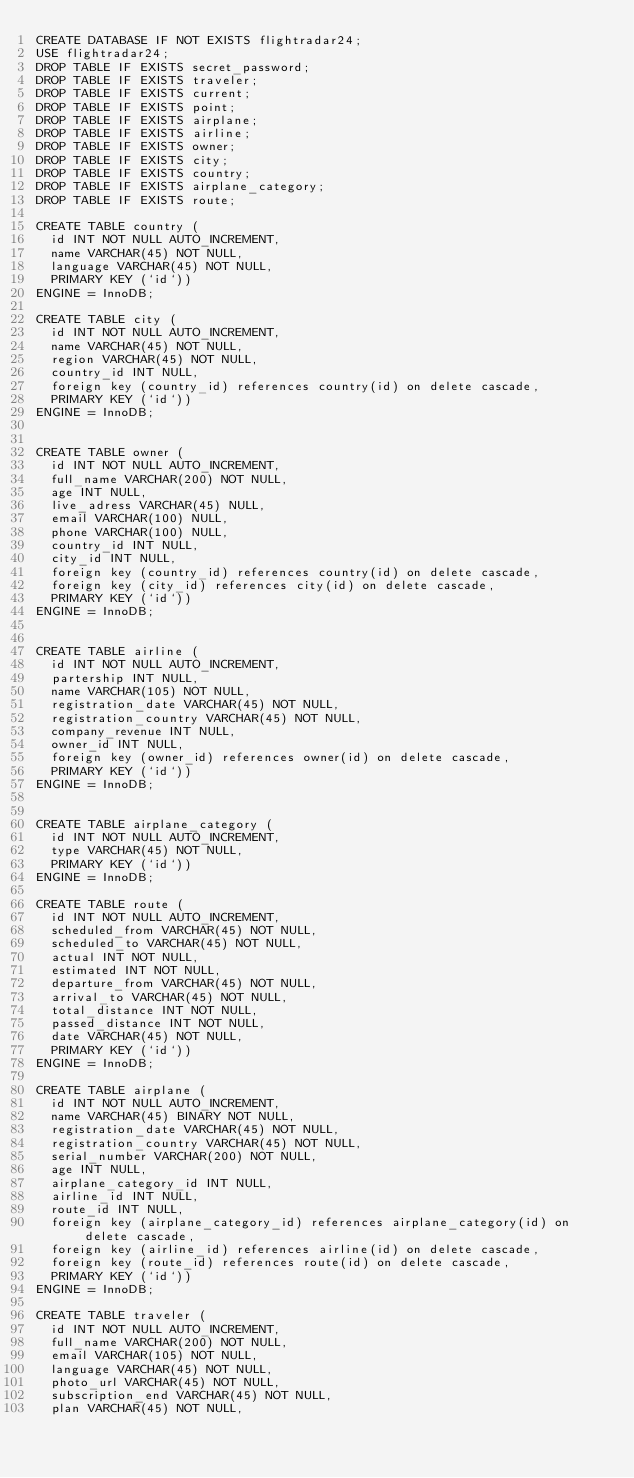<code> <loc_0><loc_0><loc_500><loc_500><_SQL_>CREATE DATABASE IF NOT EXISTS flightradar24;
USE flightradar24;
DROP TABLE IF EXISTS secret_password;
DROP TABLE IF EXISTS traveler;
DROP TABLE IF EXISTS current;
DROP TABLE IF EXISTS point;
DROP TABLE IF EXISTS airplane;
DROP TABLE IF EXISTS airline;
DROP TABLE IF EXISTS owner;
DROP TABLE IF EXISTS city;
DROP TABLE IF EXISTS country;
DROP TABLE IF EXISTS airplane_category;
DROP TABLE IF EXISTS route;

CREATE TABLE country (
  id INT NOT NULL AUTO_INCREMENT,
  name VARCHAR(45) NOT NULL,
  language VARCHAR(45) NOT NULL,
  PRIMARY KEY (`id`))
ENGINE = InnoDB;

CREATE TABLE city (
  id INT NOT NULL AUTO_INCREMENT,
  name VARCHAR(45) NOT NULL,
  region VARCHAR(45) NOT NULL,
  country_id INT NULL,
  foreign key (country_id) references country(id) on delete cascade,
  PRIMARY KEY (`id`))
ENGINE = InnoDB;


CREATE TABLE owner (
  id INT NOT NULL AUTO_INCREMENT,
  full_name VARCHAR(200) NOT NULL,
  age INT NULL,
  live_adress VARCHAR(45) NULL,
  email VARCHAR(100) NULL,
  phone VARCHAR(100) NULL,
  country_id INT NULL,
  city_id INT NULL,
  foreign key (country_id) references country(id) on delete cascade,
  foreign key (city_id) references city(id) on delete cascade,
  PRIMARY KEY (`id`))
ENGINE = InnoDB;


CREATE TABLE airline (
  id INT NOT NULL AUTO_INCREMENT,
  partership INT NULL,
  name VARCHAR(105) NOT NULL,
  registration_date VARCHAR(45) NOT NULL,
  registration_country VARCHAR(45) NOT NULL,
  company_revenue INT NULL,
  owner_id INT NULL,
  foreign key (owner_id) references owner(id) on delete cascade,
  PRIMARY KEY (`id`))
ENGINE = InnoDB;


CREATE TABLE airplane_category (
  id INT NOT NULL AUTO_INCREMENT,
  type VARCHAR(45) NOT NULL,
  PRIMARY KEY (`id`))
ENGINE = InnoDB;

CREATE TABLE route (
  id INT NOT NULL AUTO_INCREMENT,
  scheduled_from VARCHAR(45) NOT NULL,
  scheduled_to VARCHAR(45) NOT NULL,
  actual INT NOT NULL,
  estimated INT NOT NULL,
  departure_from VARCHAR(45) NOT NULL,
  arrival_to VARCHAR(45) NOT NULL,
  total_distance INT NOT NULL,
  passed_distance INT NOT NULL,
  date VARCHAR(45) NOT NULL,
  PRIMARY KEY (`id`))
ENGINE = InnoDB;

CREATE TABLE airplane (
  id INT NOT NULL AUTO_INCREMENT,
  name VARCHAR(45) BINARY NOT NULL,
  registration_date VARCHAR(45) NOT NULL,
  registration_country VARCHAR(45) NOT NULL,
  serial_number VARCHAR(200) NOT NULL,
  age INT NULL,
  airplane_category_id INT NULL,
  airline_id INT NULL,
  route_id INT NULL,
  foreign key (airplane_category_id) references airplane_category(id) on delete cascade,
  foreign key (airline_id) references airline(id) on delete cascade,
  foreign key (route_id) references route(id) on delete cascade,
  PRIMARY KEY (`id`))
ENGINE = InnoDB;

CREATE TABLE traveler (
  id INT NOT NULL AUTO_INCREMENT,
  full_name VARCHAR(200) NOT NULL,
  email VARCHAR(105) NOT NULL,
  language VARCHAR(45) NOT NULL,
  photo_url VARCHAR(45) NOT NULL,
  subscription_end VARCHAR(45) NOT NULL,
  plan VARCHAR(45) NOT NULL,</code> 